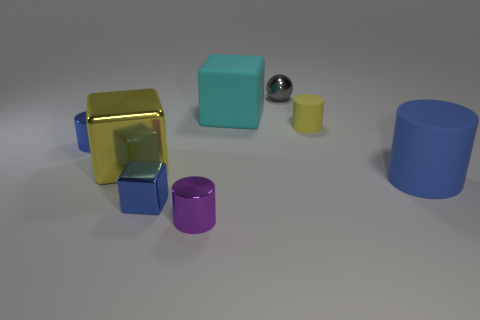What number of things have the same color as the tiny matte cylinder?
Your response must be concise. 1. There is a shiny cylinder that is to the left of the large yellow metallic thing; does it have the same size as the yellow object to the right of the large cyan object?
Offer a terse response. Yes. Is the number of big metal objects to the right of the tiny purple shiny cylinder less than the number of tiny yellow cylinders in front of the yellow metal block?
Ensure brevity in your answer.  No. There is a large cylinder that is the same color as the tiny shiny block; what is it made of?
Provide a succinct answer. Rubber. What color is the cylinder that is on the right side of the small yellow matte thing?
Give a very brief answer. Blue. Is the color of the large metallic cube the same as the small metallic cube?
Offer a terse response. No. What number of big shiny cubes are behind the large rubber object behind the blue thing right of the gray shiny sphere?
Make the answer very short. 0. The purple metal cylinder is what size?
Your answer should be compact. Small. There is a blue cube that is the same size as the gray metal sphere; what is its material?
Keep it short and to the point. Metal. There is a tiny blue shiny block; how many small balls are on the right side of it?
Provide a succinct answer. 1. 